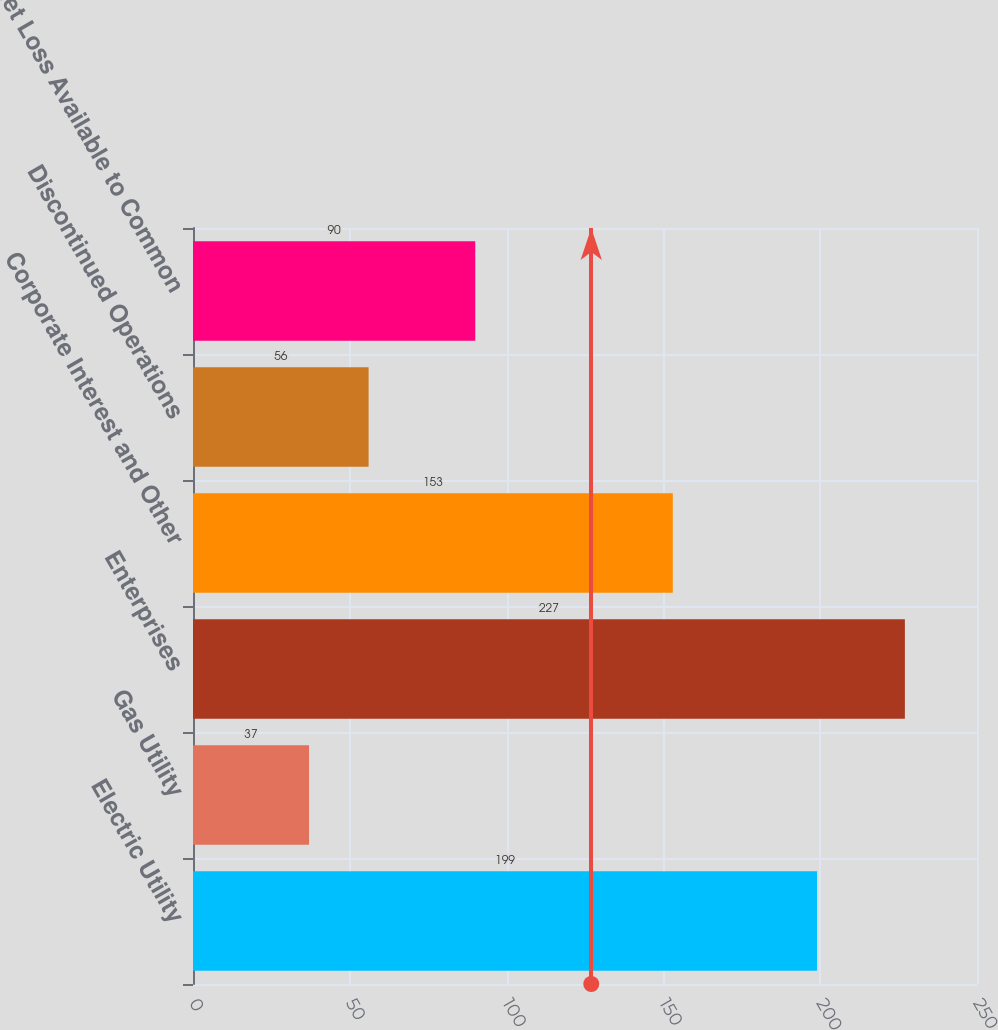<chart> <loc_0><loc_0><loc_500><loc_500><bar_chart><fcel>Electric Utility<fcel>Gas Utility<fcel>Enterprises<fcel>Corporate Interest and Other<fcel>Discontinued Operations<fcel>Net Loss Available to Common<nl><fcel>199<fcel>37<fcel>227<fcel>153<fcel>56<fcel>90<nl></chart> 